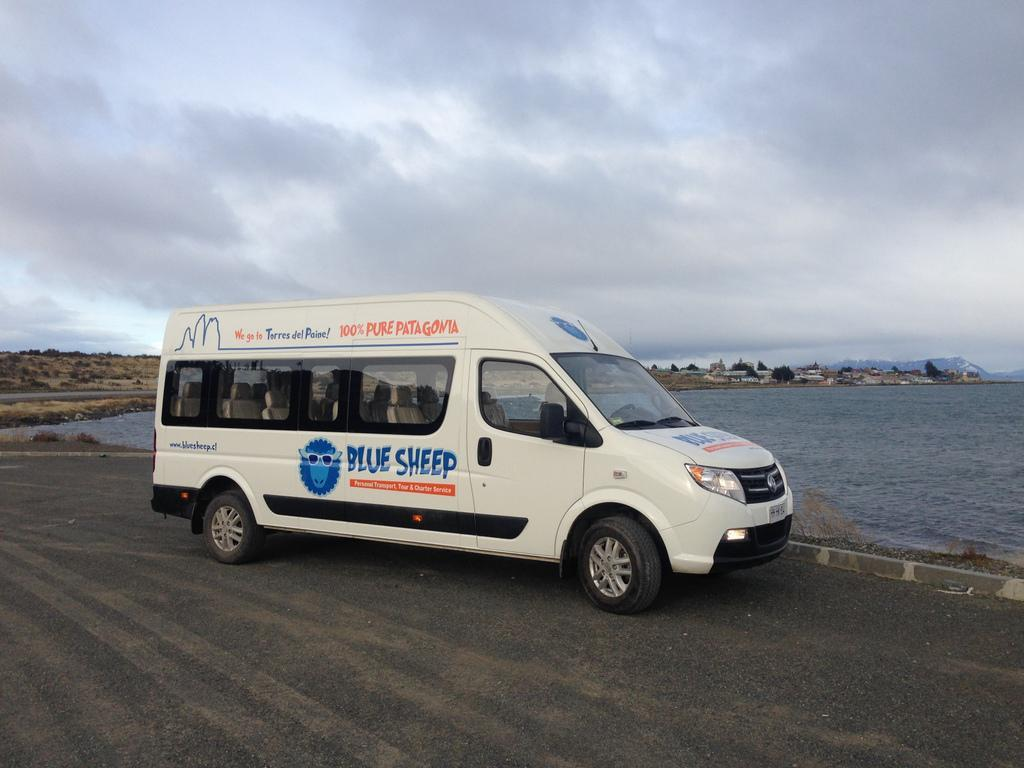<image>
Offer a succinct explanation of the picture presented. A passenger van that reads, "Blue Sheep" sits on a road next to water. 